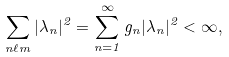<formula> <loc_0><loc_0><loc_500><loc_500>\sum _ { n \ell m } | \lambda _ { n } | ^ { 2 } = \sum _ { n = 1 } ^ { \infty } g _ { n } | \lambda _ { n } | ^ { 2 } < \infty ,</formula> 